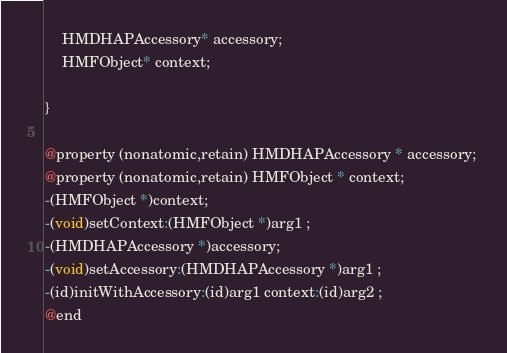<code> <loc_0><loc_0><loc_500><loc_500><_C_>	HMDHAPAccessory* accessory;
	HMFObject* context;

}

@property (nonatomic,retain) HMDHAPAccessory * accessory; 
@property (nonatomic,retain) HMFObject * context; 
-(HMFObject *)context;
-(void)setContext:(HMFObject *)arg1 ;
-(HMDHAPAccessory *)accessory;
-(void)setAccessory:(HMDHAPAccessory *)arg1 ;
-(id)initWithAccessory:(id)arg1 context:(id)arg2 ;
@end

</code> 